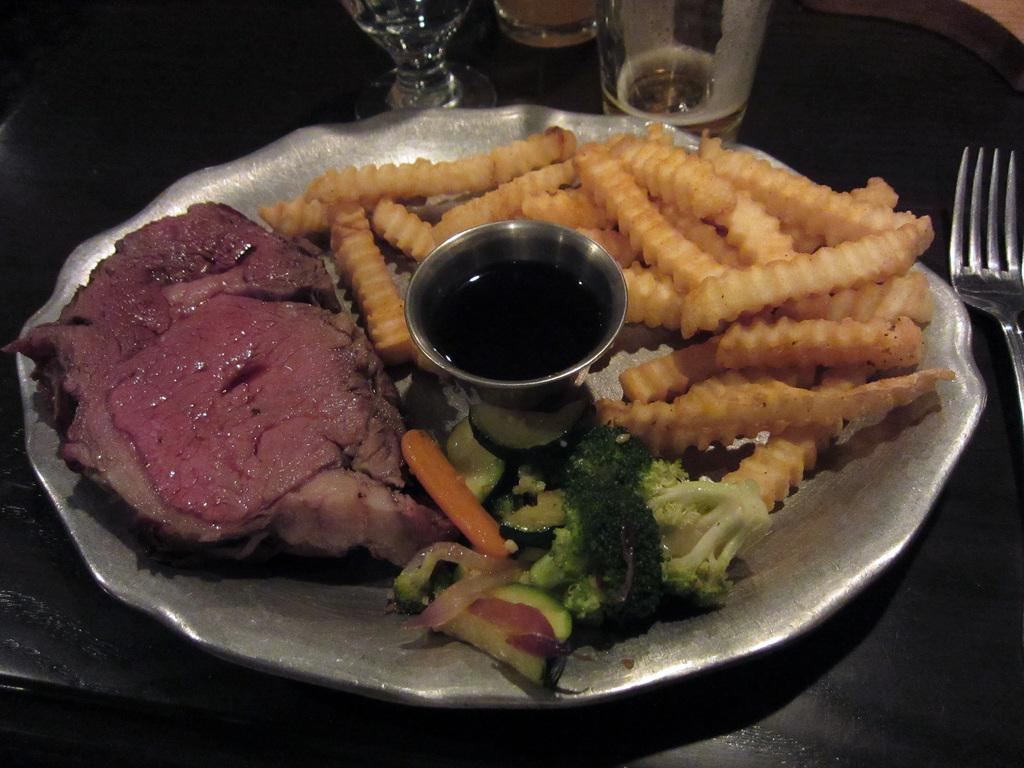What types of food items can be seen in the image? There are food items in the image, but their specific types cannot be determined from the provided facts. What is contained in the glass in the image? There is a glass with a liquid in the image. Where is the glass placed in the image? The glass is on a plate in the image. What utensil is present in the image? There is a fork in the image. How many glasses are visible on the table in the image? There are glasses on the table in the image, but the exact number cannot be determined from the provided facts. What type of toothbrush is being used to eat the food in the image? There is no toothbrush present in the image, and toothbrushes are not used for eating food. 